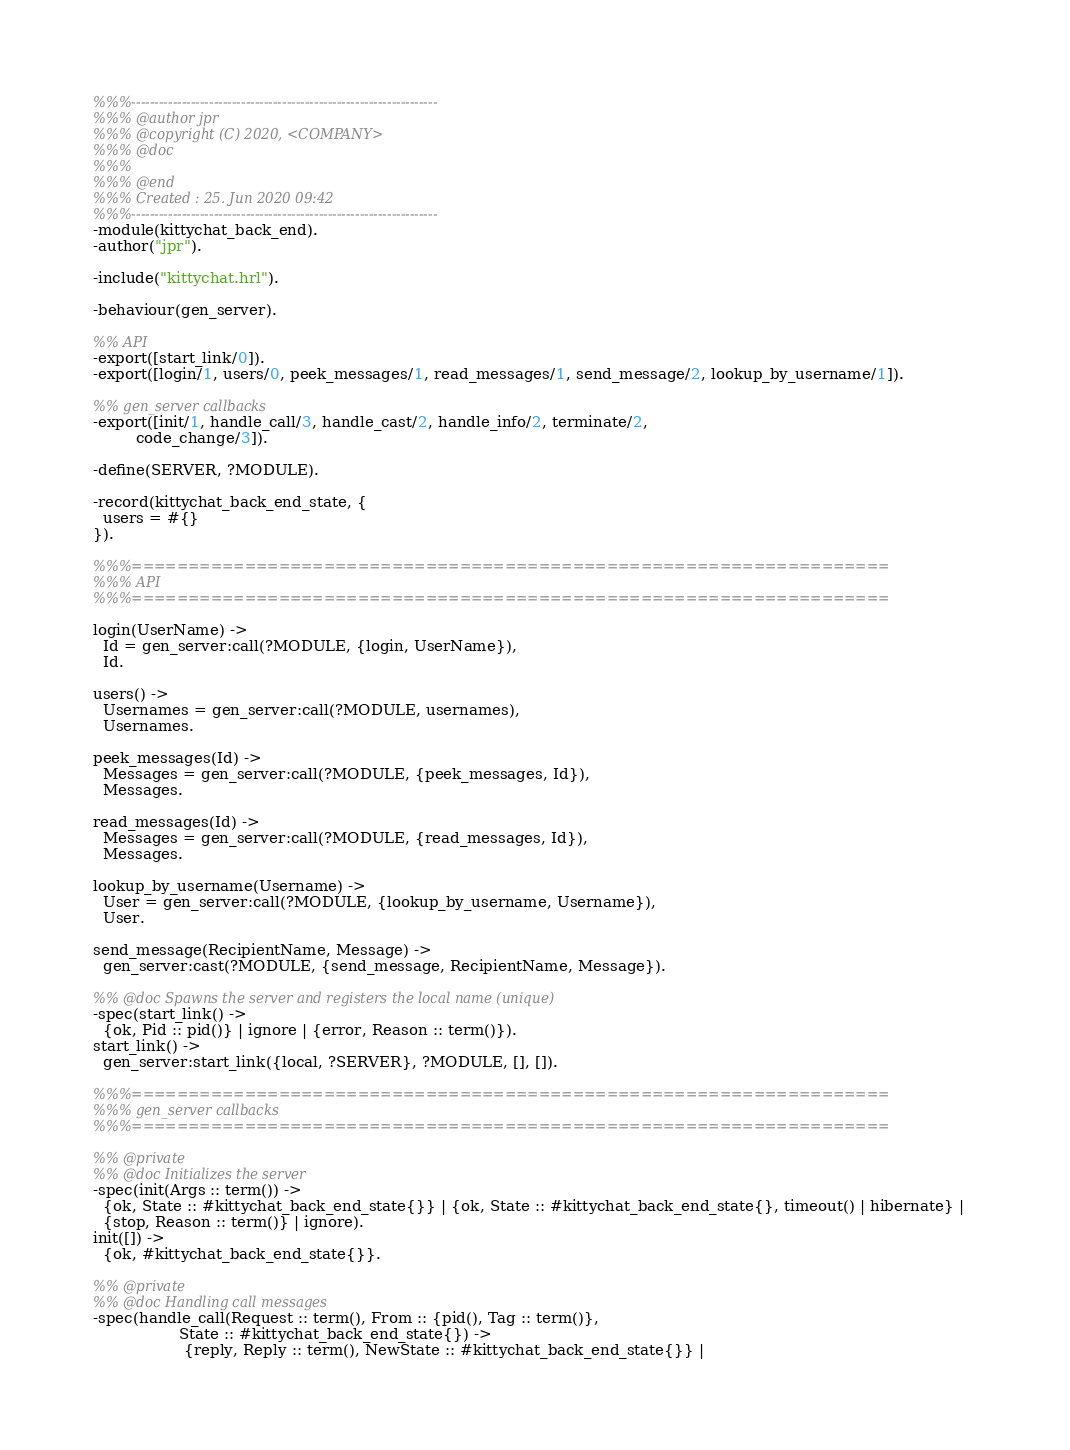Convert code to text. <code><loc_0><loc_0><loc_500><loc_500><_Erlang_>%%%-------------------------------------------------------------------
%%% @author jpr
%%% @copyright (C) 2020, <COMPANY>
%%% @doc
%%%
%%% @end
%%% Created : 25. Jun 2020 09:42
%%%-------------------------------------------------------------------
-module(kittychat_back_end).
-author("jpr").

-include("kittychat.hrl").

-behaviour(gen_server).

%% API
-export([start_link/0]).
-export([login/1, users/0, peek_messages/1, read_messages/1, send_message/2, lookup_by_username/1]).

%% gen_server callbacks
-export([init/1, handle_call/3, handle_cast/2, handle_info/2, terminate/2,
         code_change/3]).

-define(SERVER, ?MODULE).

-record(kittychat_back_end_state, {
  users = #{}
}).

%%%===================================================================
%%% API
%%%===================================================================

login(UserName) ->
  Id = gen_server:call(?MODULE, {login, UserName}),
  Id.

users() ->
  Usernames = gen_server:call(?MODULE, usernames),
  Usernames.

peek_messages(Id) ->
  Messages = gen_server:call(?MODULE, {peek_messages, Id}),
  Messages.

read_messages(Id) ->
  Messages = gen_server:call(?MODULE, {read_messages, Id}),
  Messages.

lookup_by_username(Username) ->
  User = gen_server:call(?MODULE, {lookup_by_username, Username}),
  User.

send_message(RecipientName, Message) ->
  gen_server:cast(?MODULE, {send_message, RecipientName, Message}).

%% @doc Spawns the server and registers the local name (unique)
-spec(start_link() ->
  {ok, Pid :: pid()} | ignore | {error, Reason :: term()}).
start_link() ->
  gen_server:start_link({local, ?SERVER}, ?MODULE, [], []).

%%%===================================================================
%%% gen_server callbacks
%%%===================================================================

%% @private
%% @doc Initializes the server
-spec(init(Args :: term()) ->
  {ok, State :: #kittychat_back_end_state{}} | {ok, State :: #kittychat_back_end_state{}, timeout() | hibernate} |
  {stop, Reason :: term()} | ignore).
init([]) ->
  {ok, #kittychat_back_end_state{}}.

%% @private
%% @doc Handling call messages
-spec(handle_call(Request :: term(), From :: {pid(), Tag :: term()},
                  State :: #kittychat_back_end_state{}) ->
                   {reply, Reply :: term(), NewState :: #kittychat_back_end_state{}} |</code> 